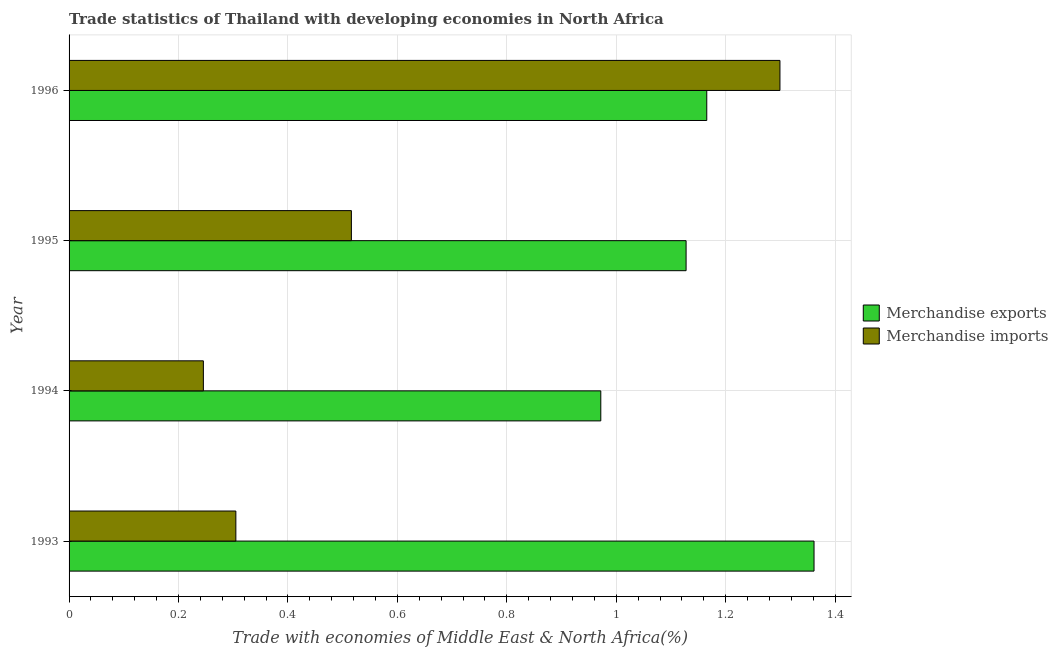How many different coloured bars are there?
Give a very brief answer. 2. What is the label of the 1st group of bars from the top?
Ensure brevity in your answer.  1996. What is the merchandise exports in 1995?
Provide a short and direct response. 1.13. Across all years, what is the maximum merchandise imports?
Provide a succinct answer. 1.3. Across all years, what is the minimum merchandise exports?
Offer a terse response. 0.97. In which year was the merchandise imports maximum?
Offer a very short reply. 1996. What is the total merchandise imports in the graph?
Offer a terse response. 2.37. What is the difference between the merchandise exports in 1993 and that in 1994?
Make the answer very short. 0.39. What is the difference between the merchandise imports in 1995 and the merchandise exports in 1996?
Give a very brief answer. -0.65. What is the average merchandise exports per year?
Keep it short and to the point. 1.16. In the year 1996, what is the difference between the merchandise exports and merchandise imports?
Give a very brief answer. -0.13. What is the ratio of the merchandise imports in 1993 to that in 1994?
Offer a terse response. 1.24. Is the merchandise exports in 1993 less than that in 1996?
Ensure brevity in your answer.  No. Is the difference between the merchandise exports in 1993 and 1995 greater than the difference between the merchandise imports in 1993 and 1995?
Your answer should be very brief. Yes. What is the difference between the highest and the second highest merchandise exports?
Provide a succinct answer. 0.2. Is the sum of the merchandise exports in 1994 and 1995 greater than the maximum merchandise imports across all years?
Provide a short and direct response. Yes. What does the 2nd bar from the bottom in 1993 represents?
Provide a short and direct response. Merchandise imports. What is the difference between two consecutive major ticks on the X-axis?
Your response must be concise. 0.2. Are the values on the major ticks of X-axis written in scientific E-notation?
Your answer should be compact. No. Does the graph contain any zero values?
Give a very brief answer. No. Where does the legend appear in the graph?
Your answer should be compact. Center right. How many legend labels are there?
Provide a short and direct response. 2. How are the legend labels stacked?
Offer a terse response. Vertical. What is the title of the graph?
Your response must be concise. Trade statistics of Thailand with developing economies in North Africa. What is the label or title of the X-axis?
Your answer should be compact. Trade with economies of Middle East & North Africa(%). What is the label or title of the Y-axis?
Keep it short and to the point. Year. What is the Trade with economies of Middle East & North Africa(%) of Merchandise exports in 1993?
Your answer should be very brief. 1.36. What is the Trade with economies of Middle East & North Africa(%) of Merchandise imports in 1993?
Keep it short and to the point. 0.3. What is the Trade with economies of Middle East & North Africa(%) in Merchandise exports in 1994?
Ensure brevity in your answer.  0.97. What is the Trade with economies of Middle East & North Africa(%) of Merchandise imports in 1994?
Offer a terse response. 0.25. What is the Trade with economies of Middle East & North Africa(%) of Merchandise exports in 1995?
Your response must be concise. 1.13. What is the Trade with economies of Middle East & North Africa(%) in Merchandise imports in 1995?
Ensure brevity in your answer.  0.52. What is the Trade with economies of Middle East & North Africa(%) of Merchandise exports in 1996?
Keep it short and to the point. 1.17. What is the Trade with economies of Middle East & North Africa(%) of Merchandise imports in 1996?
Provide a short and direct response. 1.3. Across all years, what is the maximum Trade with economies of Middle East & North Africa(%) in Merchandise exports?
Keep it short and to the point. 1.36. Across all years, what is the maximum Trade with economies of Middle East & North Africa(%) of Merchandise imports?
Offer a very short reply. 1.3. Across all years, what is the minimum Trade with economies of Middle East & North Africa(%) in Merchandise exports?
Keep it short and to the point. 0.97. Across all years, what is the minimum Trade with economies of Middle East & North Africa(%) of Merchandise imports?
Give a very brief answer. 0.25. What is the total Trade with economies of Middle East & North Africa(%) in Merchandise exports in the graph?
Your answer should be very brief. 4.63. What is the total Trade with economies of Middle East & North Africa(%) in Merchandise imports in the graph?
Offer a very short reply. 2.37. What is the difference between the Trade with economies of Middle East & North Africa(%) in Merchandise exports in 1993 and that in 1994?
Your answer should be compact. 0.39. What is the difference between the Trade with economies of Middle East & North Africa(%) of Merchandise imports in 1993 and that in 1994?
Make the answer very short. 0.06. What is the difference between the Trade with economies of Middle East & North Africa(%) in Merchandise exports in 1993 and that in 1995?
Offer a very short reply. 0.23. What is the difference between the Trade with economies of Middle East & North Africa(%) in Merchandise imports in 1993 and that in 1995?
Offer a terse response. -0.21. What is the difference between the Trade with economies of Middle East & North Africa(%) in Merchandise exports in 1993 and that in 1996?
Provide a succinct answer. 0.2. What is the difference between the Trade with economies of Middle East & North Africa(%) of Merchandise imports in 1993 and that in 1996?
Your response must be concise. -0.99. What is the difference between the Trade with economies of Middle East & North Africa(%) of Merchandise exports in 1994 and that in 1995?
Make the answer very short. -0.16. What is the difference between the Trade with economies of Middle East & North Africa(%) of Merchandise imports in 1994 and that in 1995?
Your answer should be very brief. -0.27. What is the difference between the Trade with economies of Middle East & North Africa(%) in Merchandise exports in 1994 and that in 1996?
Your answer should be compact. -0.19. What is the difference between the Trade with economies of Middle East & North Africa(%) of Merchandise imports in 1994 and that in 1996?
Offer a terse response. -1.05. What is the difference between the Trade with economies of Middle East & North Africa(%) of Merchandise exports in 1995 and that in 1996?
Provide a succinct answer. -0.04. What is the difference between the Trade with economies of Middle East & North Africa(%) of Merchandise imports in 1995 and that in 1996?
Ensure brevity in your answer.  -0.78. What is the difference between the Trade with economies of Middle East & North Africa(%) of Merchandise exports in 1993 and the Trade with economies of Middle East & North Africa(%) of Merchandise imports in 1994?
Offer a very short reply. 1.12. What is the difference between the Trade with economies of Middle East & North Africa(%) of Merchandise exports in 1993 and the Trade with economies of Middle East & North Africa(%) of Merchandise imports in 1995?
Provide a short and direct response. 0.85. What is the difference between the Trade with economies of Middle East & North Africa(%) of Merchandise exports in 1993 and the Trade with economies of Middle East & North Africa(%) of Merchandise imports in 1996?
Ensure brevity in your answer.  0.06. What is the difference between the Trade with economies of Middle East & North Africa(%) in Merchandise exports in 1994 and the Trade with economies of Middle East & North Africa(%) in Merchandise imports in 1995?
Give a very brief answer. 0.46. What is the difference between the Trade with economies of Middle East & North Africa(%) of Merchandise exports in 1994 and the Trade with economies of Middle East & North Africa(%) of Merchandise imports in 1996?
Your response must be concise. -0.33. What is the difference between the Trade with economies of Middle East & North Africa(%) of Merchandise exports in 1995 and the Trade with economies of Middle East & North Africa(%) of Merchandise imports in 1996?
Your response must be concise. -0.17. What is the average Trade with economies of Middle East & North Africa(%) in Merchandise exports per year?
Your response must be concise. 1.16. What is the average Trade with economies of Middle East & North Africa(%) of Merchandise imports per year?
Make the answer very short. 0.59. In the year 1993, what is the difference between the Trade with economies of Middle East & North Africa(%) of Merchandise exports and Trade with economies of Middle East & North Africa(%) of Merchandise imports?
Offer a very short reply. 1.06. In the year 1994, what is the difference between the Trade with economies of Middle East & North Africa(%) of Merchandise exports and Trade with economies of Middle East & North Africa(%) of Merchandise imports?
Your response must be concise. 0.73. In the year 1995, what is the difference between the Trade with economies of Middle East & North Africa(%) in Merchandise exports and Trade with economies of Middle East & North Africa(%) in Merchandise imports?
Keep it short and to the point. 0.61. In the year 1996, what is the difference between the Trade with economies of Middle East & North Africa(%) of Merchandise exports and Trade with economies of Middle East & North Africa(%) of Merchandise imports?
Offer a very short reply. -0.13. What is the ratio of the Trade with economies of Middle East & North Africa(%) in Merchandise exports in 1993 to that in 1994?
Ensure brevity in your answer.  1.4. What is the ratio of the Trade with economies of Middle East & North Africa(%) of Merchandise imports in 1993 to that in 1994?
Keep it short and to the point. 1.24. What is the ratio of the Trade with economies of Middle East & North Africa(%) of Merchandise exports in 1993 to that in 1995?
Keep it short and to the point. 1.21. What is the ratio of the Trade with economies of Middle East & North Africa(%) in Merchandise imports in 1993 to that in 1995?
Keep it short and to the point. 0.59. What is the ratio of the Trade with economies of Middle East & North Africa(%) in Merchandise exports in 1993 to that in 1996?
Give a very brief answer. 1.17. What is the ratio of the Trade with economies of Middle East & North Africa(%) of Merchandise imports in 1993 to that in 1996?
Provide a short and direct response. 0.23. What is the ratio of the Trade with economies of Middle East & North Africa(%) in Merchandise exports in 1994 to that in 1995?
Provide a short and direct response. 0.86. What is the ratio of the Trade with economies of Middle East & North Africa(%) in Merchandise imports in 1994 to that in 1995?
Ensure brevity in your answer.  0.48. What is the ratio of the Trade with economies of Middle East & North Africa(%) of Merchandise exports in 1994 to that in 1996?
Your answer should be very brief. 0.83. What is the ratio of the Trade with economies of Middle East & North Africa(%) in Merchandise imports in 1994 to that in 1996?
Your response must be concise. 0.19. What is the ratio of the Trade with economies of Middle East & North Africa(%) in Merchandise exports in 1995 to that in 1996?
Make the answer very short. 0.97. What is the ratio of the Trade with economies of Middle East & North Africa(%) of Merchandise imports in 1995 to that in 1996?
Your response must be concise. 0.4. What is the difference between the highest and the second highest Trade with economies of Middle East & North Africa(%) of Merchandise exports?
Offer a very short reply. 0.2. What is the difference between the highest and the second highest Trade with economies of Middle East & North Africa(%) of Merchandise imports?
Ensure brevity in your answer.  0.78. What is the difference between the highest and the lowest Trade with economies of Middle East & North Africa(%) in Merchandise exports?
Make the answer very short. 0.39. What is the difference between the highest and the lowest Trade with economies of Middle East & North Africa(%) of Merchandise imports?
Your answer should be very brief. 1.05. 